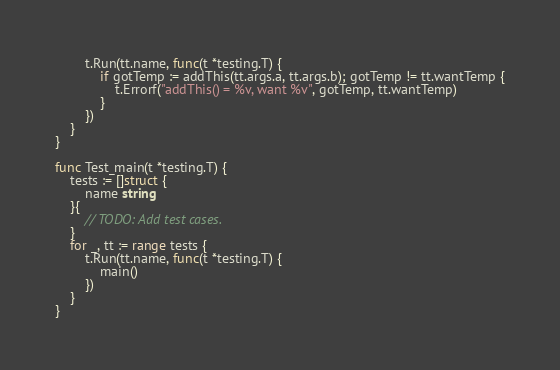Convert code to text. <code><loc_0><loc_0><loc_500><loc_500><_Go_>		t.Run(tt.name, func(t *testing.T) {
			if gotTemp := addThis(tt.args.a, tt.args.b); gotTemp != tt.wantTemp {
				t.Errorf("addThis() = %v, want %v", gotTemp, tt.wantTemp)
			}
		})
	}
}

func Test_main(t *testing.T) {
	tests := []struct {
		name string
	}{
		// TODO: Add test cases.
	}
	for _, tt := range tests {
		t.Run(tt.name, func(t *testing.T) {
			main()
		})
	}
}
</code> 